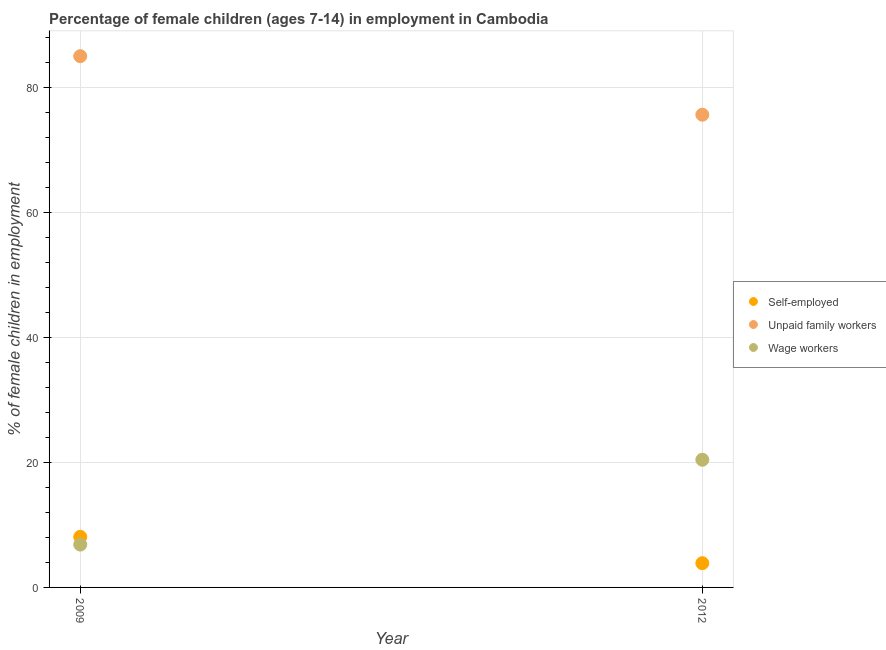Is the number of dotlines equal to the number of legend labels?
Provide a succinct answer. Yes. What is the percentage of children employed as wage workers in 2009?
Your response must be concise. 6.86. Across all years, what is the minimum percentage of children employed as wage workers?
Your response must be concise. 6.86. In which year was the percentage of self employed children maximum?
Give a very brief answer. 2009. What is the total percentage of self employed children in the graph?
Provide a short and direct response. 11.98. What is the difference between the percentage of children employed as wage workers in 2009 and that in 2012?
Offer a very short reply. -13.58. What is the difference between the percentage of children employed as unpaid family workers in 2012 and the percentage of children employed as wage workers in 2009?
Your answer should be very brief. 68.81. What is the average percentage of children employed as unpaid family workers per year?
Give a very brief answer. 80.36. In the year 2009, what is the difference between the percentage of children employed as unpaid family workers and percentage of self employed children?
Your response must be concise. 76.94. What is the ratio of the percentage of children employed as wage workers in 2009 to that in 2012?
Give a very brief answer. 0.34. In how many years, is the percentage of children employed as unpaid family workers greater than the average percentage of children employed as unpaid family workers taken over all years?
Your answer should be very brief. 1. Is it the case that in every year, the sum of the percentage of self employed children and percentage of children employed as unpaid family workers is greater than the percentage of children employed as wage workers?
Make the answer very short. Yes. Does the percentage of children employed as unpaid family workers monotonically increase over the years?
Provide a succinct answer. No. How many dotlines are there?
Offer a terse response. 3. Are the values on the major ticks of Y-axis written in scientific E-notation?
Keep it short and to the point. No. How are the legend labels stacked?
Keep it short and to the point. Vertical. What is the title of the graph?
Make the answer very short. Percentage of female children (ages 7-14) in employment in Cambodia. Does "Oil" appear as one of the legend labels in the graph?
Provide a short and direct response. No. What is the label or title of the X-axis?
Your response must be concise. Year. What is the label or title of the Y-axis?
Provide a short and direct response. % of female children in employment. What is the % of female children in employment of Unpaid family workers in 2009?
Your response must be concise. 85.04. What is the % of female children in employment in Wage workers in 2009?
Provide a succinct answer. 6.86. What is the % of female children in employment of Self-employed in 2012?
Offer a terse response. 3.88. What is the % of female children in employment in Unpaid family workers in 2012?
Keep it short and to the point. 75.67. What is the % of female children in employment of Wage workers in 2012?
Your answer should be compact. 20.44. Across all years, what is the maximum % of female children in employment of Self-employed?
Provide a short and direct response. 8.1. Across all years, what is the maximum % of female children in employment in Unpaid family workers?
Provide a succinct answer. 85.04. Across all years, what is the maximum % of female children in employment of Wage workers?
Give a very brief answer. 20.44. Across all years, what is the minimum % of female children in employment in Self-employed?
Make the answer very short. 3.88. Across all years, what is the minimum % of female children in employment of Unpaid family workers?
Provide a succinct answer. 75.67. Across all years, what is the minimum % of female children in employment in Wage workers?
Keep it short and to the point. 6.86. What is the total % of female children in employment in Self-employed in the graph?
Make the answer very short. 11.98. What is the total % of female children in employment in Unpaid family workers in the graph?
Provide a short and direct response. 160.71. What is the total % of female children in employment in Wage workers in the graph?
Provide a short and direct response. 27.3. What is the difference between the % of female children in employment of Self-employed in 2009 and that in 2012?
Your answer should be very brief. 4.22. What is the difference between the % of female children in employment in Unpaid family workers in 2009 and that in 2012?
Make the answer very short. 9.37. What is the difference between the % of female children in employment in Wage workers in 2009 and that in 2012?
Your answer should be very brief. -13.58. What is the difference between the % of female children in employment in Self-employed in 2009 and the % of female children in employment in Unpaid family workers in 2012?
Make the answer very short. -67.57. What is the difference between the % of female children in employment in Self-employed in 2009 and the % of female children in employment in Wage workers in 2012?
Make the answer very short. -12.34. What is the difference between the % of female children in employment in Unpaid family workers in 2009 and the % of female children in employment in Wage workers in 2012?
Your response must be concise. 64.6. What is the average % of female children in employment of Self-employed per year?
Provide a short and direct response. 5.99. What is the average % of female children in employment of Unpaid family workers per year?
Offer a terse response. 80.36. What is the average % of female children in employment in Wage workers per year?
Make the answer very short. 13.65. In the year 2009, what is the difference between the % of female children in employment in Self-employed and % of female children in employment in Unpaid family workers?
Your answer should be compact. -76.94. In the year 2009, what is the difference between the % of female children in employment of Self-employed and % of female children in employment of Wage workers?
Keep it short and to the point. 1.24. In the year 2009, what is the difference between the % of female children in employment in Unpaid family workers and % of female children in employment in Wage workers?
Ensure brevity in your answer.  78.18. In the year 2012, what is the difference between the % of female children in employment of Self-employed and % of female children in employment of Unpaid family workers?
Keep it short and to the point. -71.79. In the year 2012, what is the difference between the % of female children in employment of Self-employed and % of female children in employment of Wage workers?
Your answer should be very brief. -16.56. In the year 2012, what is the difference between the % of female children in employment in Unpaid family workers and % of female children in employment in Wage workers?
Make the answer very short. 55.23. What is the ratio of the % of female children in employment of Self-employed in 2009 to that in 2012?
Ensure brevity in your answer.  2.09. What is the ratio of the % of female children in employment in Unpaid family workers in 2009 to that in 2012?
Your answer should be compact. 1.12. What is the ratio of the % of female children in employment in Wage workers in 2009 to that in 2012?
Provide a succinct answer. 0.34. What is the difference between the highest and the second highest % of female children in employment of Self-employed?
Ensure brevity in your answer.  4.22. What is the difference between the highest and the second highest % of female children in employment in Unpaid family workers?
Offer a terse response. 9.37. What is the difference between the highest and the second highest % of female children in employment in Wage workers?
Ensure brevity in your answer.  13.58. What is the difference between the highest and the lowest % of female children in employment of Self-employed?
Your answer should be compact. 4.22. What is the difference between the highest and the lowest % of female children in employment of Unpaid family workers?
Keep it short and to the point. 9.37. What is the difference between the highest and the lowest % of female children in employment of Wage workers?
Give a very brief answer. 13.58. 